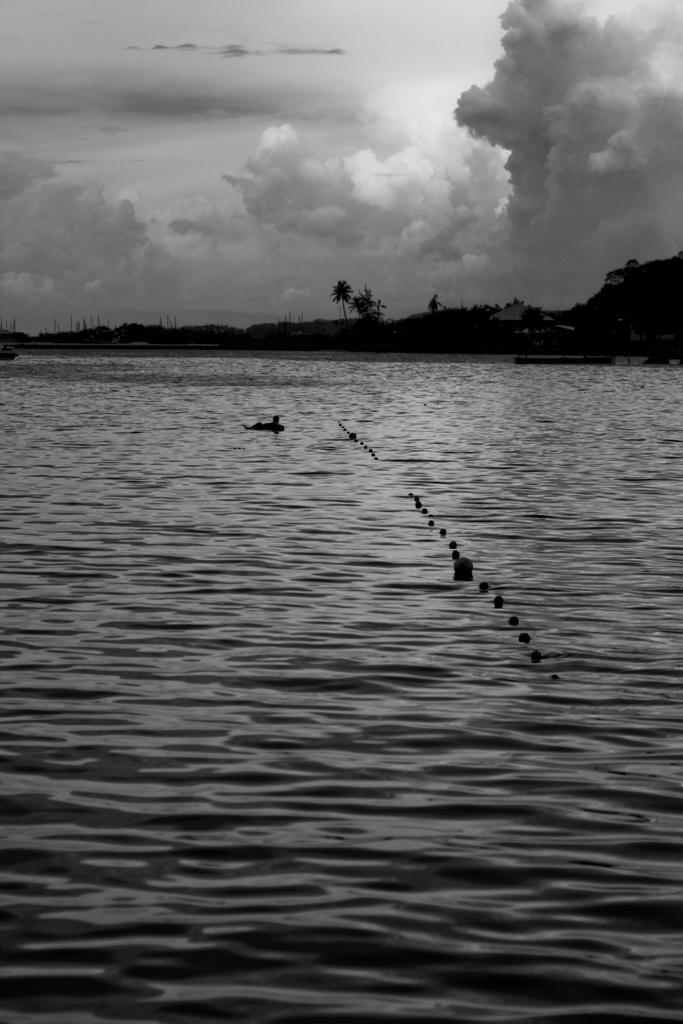How would you summarize this image in a sentence or two? In this image at the bottom there is a sea and in the sea there are birds, and in the background there are trees and poles. At the top there is sky. 